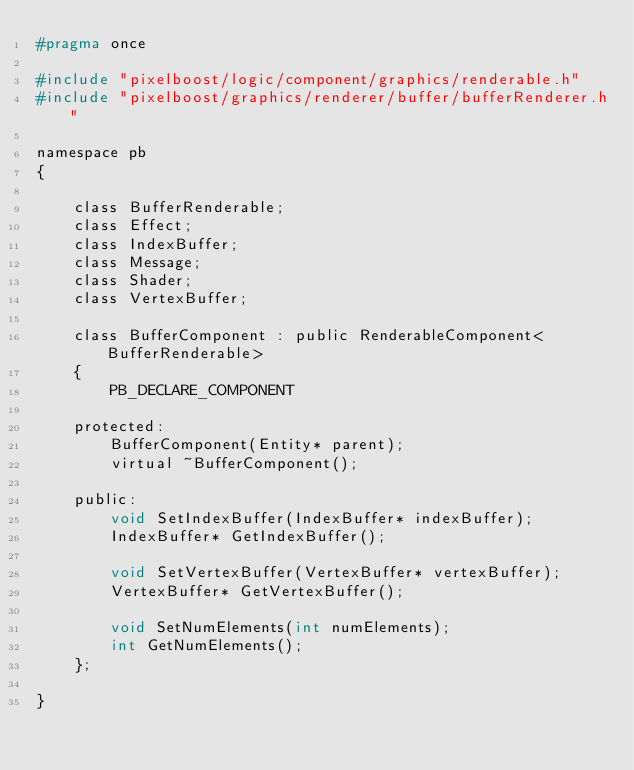Convert code to text. <code><loc_0><loc_0><loc_500><loc_500><_C_>#pragma once

#include "pixelboost/logic/component/graphics/renderable.h"
#include "pixelboost/graphics/renderer/buffer/bufferRenderer.h"

namespace pb
{
    
    class BufferRenderable;
    class Effect;
    class IndexBuffer;
    class Message;
    class Shader;
    class VertexBuffer;
    
    class BufferComponent : public RenderableComponent<BufferRenderable>
    {
        PB_DECLARE_COMPONENT
        
    protected:
        BufferComponent(Entity* parent);
        virtual ~BufferComponent();
        
    public:
        void SetIndexBuffer(IndexBuffer* indexBuffer);
        IndexBuffer* GetIndexBuffer();
        
        void SetVertexBuffer(VertexBuffer* vertexBuffer);
        VertexBuffer* GetVertexBuffer();
        
        void SetNumElements(int numElements);
        int GetNumElements();
    };
    
}
</code> 